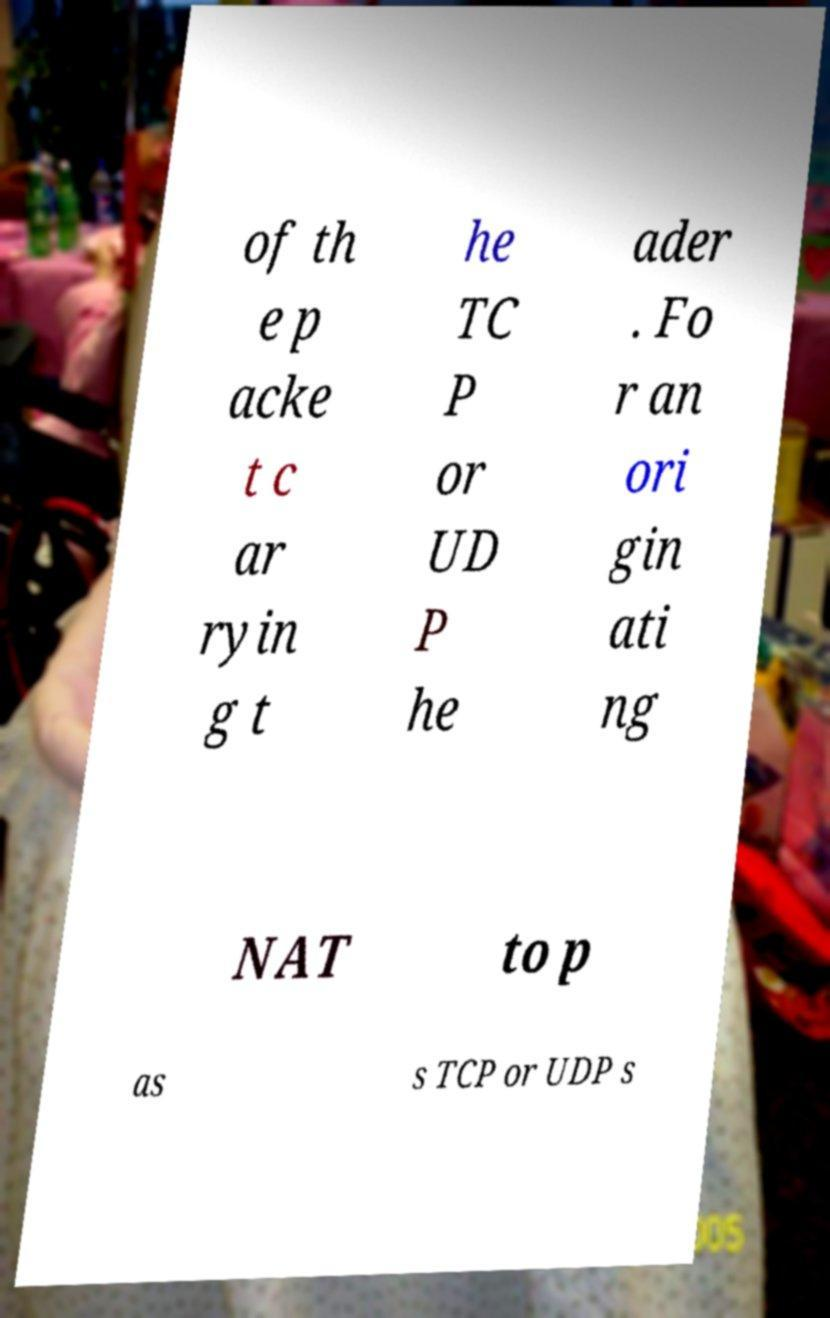There's text embedded in this image that I need extracted. Can you transcribe it verbatim? of th e p acke t c ar ryin g t he TC P or UD P he ader . Fo r an ori gin ati ng NAT to p as s TCP or UDP s 